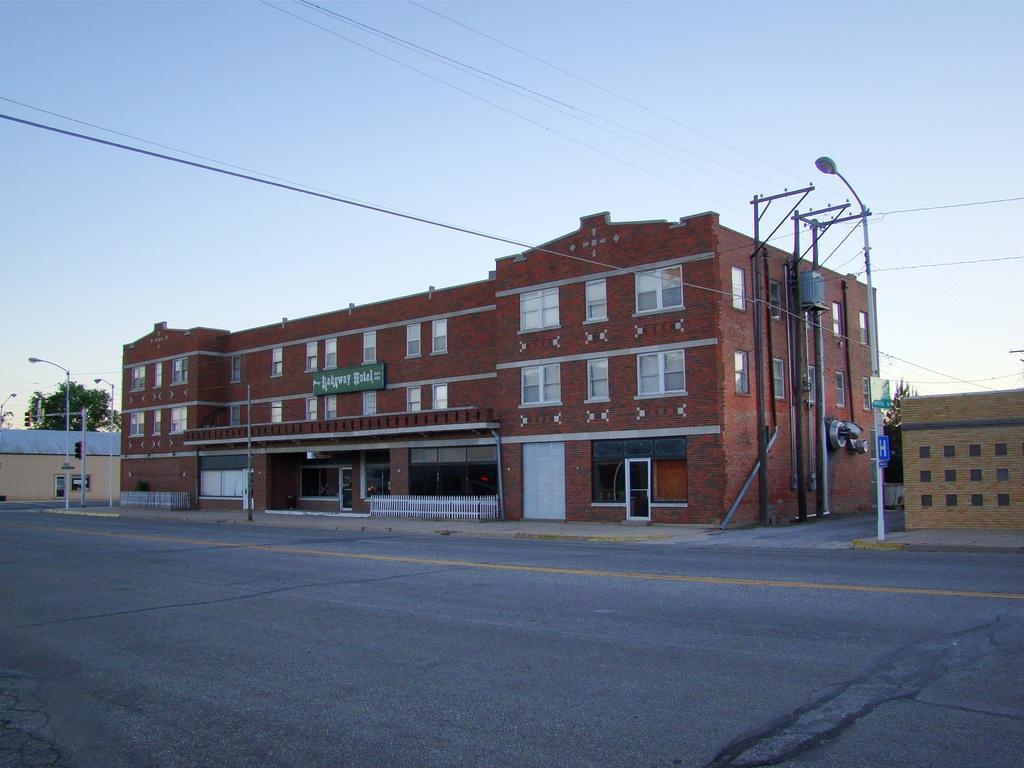Can you describe this image briefly? This picture consists of road , on the road I can see street light poles and power line cables, beside the road I can see buildings and at the top I can see the sky and on the left side I can see trees. 